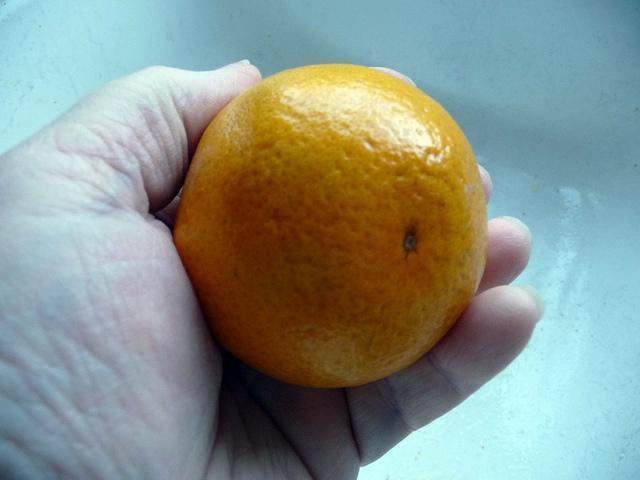Is this affirmation: "The person is touching the orange." correct?
Answer yes or no. Yes. Is the statement "The orange is at the right side of the person." accurate regarding the image?
Answer yes or no. No. 